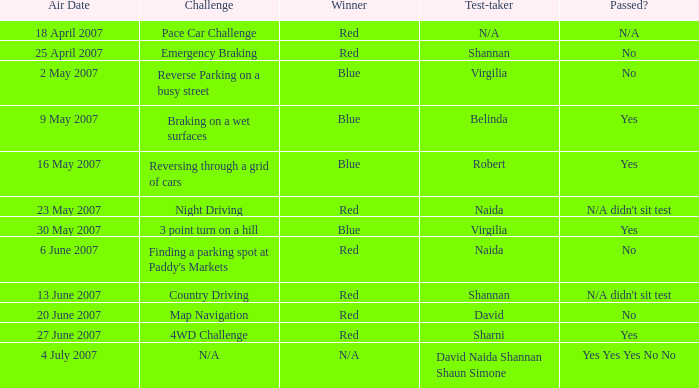On which air date was Robert the test-taker? 16 May 2007. 